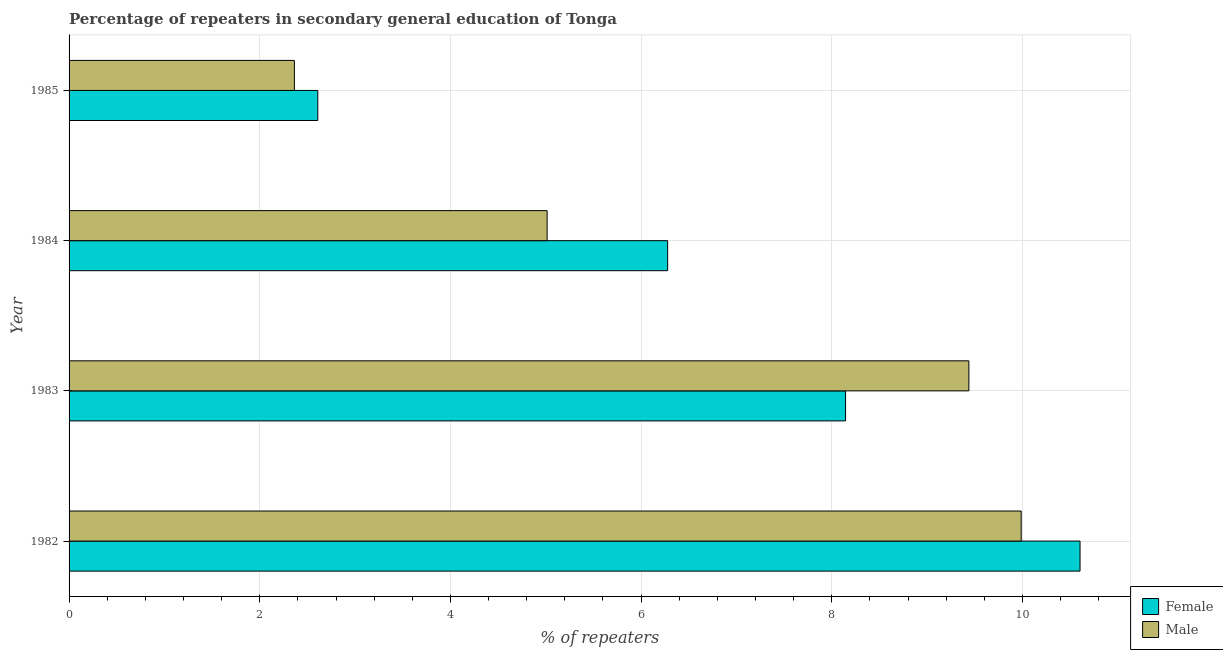How many different coloured bars are there?
Make the answer very short. 2. How many groups of bars are there?
Give a very brief answer. 4. Are the number of bars per tick equal to the number of legend labels?
Provide a short and direct response. Yes. How many bars are there on the 1st tick from the bottom?
Keep it short and to the point. 2. What is the percentage of female repeaters in 1984?
Your response must be concise. 6.28. Across all years, what is the maximum percentage of male repeaters?
Your answer should be very brief. 9.99. Across all years, what is the minimum percentage of female repeaters?
Provide a short and direct response. 2.61. What is the total percentage of male repeaters in the graph?
Provide a succinct answer. 26.8. What is the difference between the percentage of male repeaters in 1983 and that in 1985?
Provide a short and direct response. 7.08. What is the difference between the percentage of male repeaters in 1985 and the percentage of female repeaters in 1982?
Ensure brevity in your answer.  -8.24. What is the average percentage of female repeaters per year?
Your response must be concise. 6.91. In the year 1983, what is the difference between the percentage of female repeaters and percentage of male repeaters?
Your answer should be compact. -1.29. What is the ratio of the percentage of male repeaters in 1983 to that in 1985?
Keep it short and to the point. 3.99. Is the percentage of male repeaters in 1983 less than that in 1985?
Your answer should be very brief. No. What is the difference between the highest and the second highest percentage of male repeaters?
Ensure brevity in your answer.  0.55. What is the difference between the highest and the lowest percentage of male repeaters?
Offer a very short reply. 7.62. How many bars are there?
Provide a short and direct response. 8. How many years are there in the graph?
Ensure brevity in your answer.  4. What is the difference between two consecutive major ticks on the X-axis?
Your answer should be very brief. 2. Does the graph contain any zero values?
Make the answer very short. No. What is the title of the graph?
Provide a short and direct response. Percentage of repeaters in secondary general education of Tonga. What is the label or title of the X-axis?
Give a very brief answer. % of repeaters. What is the label or title of the Y-axis?
Make the answer very short. Year. What is the % of repeaters in Female in 1982?
Your answer should be very brief. 10.6. What is the % of repeaters of Male in 1982?
Provide a short and direct response. 9.99. What is the % of repeaters in Female in 1983?
Ensure brevity in your answer.  8.14. What is the % of repeaters of Male in 1983?
Make the answer very short. 9.44. What is the % of repeaters of Female in 1984?
Give a very brief answer. 6.28. What is the % of repeaters in Male in 1984?
Offer a terse response. 5.01. What is the % of repeaters in Female in 1985?
Offer a very short reply. 2.61. What is the % of repeaters in Male in 1985?
Keep it short and to the point. 2.36. Across all years, what is the maximum % of repeaters in Female?
Your answer should be very brief. 10.6. Across all years, what is the maximum % of repeaters of Male?
Provide a succinct answer. 9.99. Across all years, what is the minimum % of repeaters of Female?
Your response must be concise. 2.61. Across all years, what is the minimum % of repeaters in Male?
Ensure brevity in your answer.  2.36. What is the total % of repeaters in Female in the graph?
Your answer should be very brief. 27.64. What is the total % of repeaters in Male in the graph?
Your answer should be compact. 26.8. What is the difference between the % of repeaters in Female in 1982 and that in 1983?
Provide a short and direct response. 2.46. What is the difference between the % of repeaters of Male in 1982 and that in 1983?
Keep it short and to the point. 0.55. What is the difference between the % of repeaters of Female in 1982 and that in 1984?
Your response must be concise. 4.33. What is the difference between the % of repeaters of Male in 1982 and that in 1984?
Ensure brevity in your answer.  4.97. What is the difference between the % of repeaters of Female in 1982 and that in 1985?
Keep it short and to the point. 8. What is the difference between the % of repeaters in Male in 1982 and that in 1985?
Give a very brief answer. 7.62. What is the difference between the % of repeaters of Female in 1983 and that in 1984?
Give a very brief answer. 1.87. What is the difference between the % of repeaters in Male in 1983 and that in 1984?
Ensure brevity in your answer.  4.42. What is the difference between the % of repeaters of Female in 1983 and that in 1985?
Provide a short and direct response. 5.54. What is the difference between the % of repeaters of Male in 1983 and that in 1985?
Make the answer very short. 7.08. What is the difference between the % of repeaters in Female in 1984 and that in 1985?
Keep it short and to the point. 3.67. What is the difference between the % of repeaters of Male in 1984 and that in 1985?
Make the answer very short. 2.65. What is the difference between the % of repeaters in Female in 1982 and the % of repeaters in Male in 1983?
Your answer should be compact. 1.17. What is the difference between the % of repeaters of Female in 1982 and the % of repeaters of Male in 1984?
Make the answer very short. 5.59. What is the difference between the % of repeaters in Female in 1982 and the % of repeaters in Male in 1985?
Your answer should be compact. 8.24. What is the difference between the % of repeaters in Female in 1983 and the % of repeaters in Male in 1984?
Offer a terse response. 3.13. What is the difference between the % of repeaters in Female in 1983 and the % of repeaters in Male in 1985?
Provide a short and direct response. 5.78. What is the difference between the % of repeaters in Female in 1984 and the % of repeaters in Male in 1985?
Provide a succinct answer. 3.92. What is the average % of repeaters of Female per year?
Make the answer very short. 6.91. What is the average % of repeaters of Male per year?
Your answer should be very brief. 6.7. In the year 1982, what is the difference between the % of repeaters in Female and % of repeaters in Male?
Ensure brevity in your answer.  0.62. In the year 1983, what is the difference between the % of repeaters in Female and % of repeaters in Male?
Your answer should be very brief. -1.29. In the year 1984, what is the difference between the % of repeaters in Female and % of repeaters in Male?
Your answer should be very brief. 1.26. In the year 1985, what is the difference between the % of repeaters of Female and % of repeaters of Male?
Your response must be concise. 0.25. What is the ratio of the % of repeaters of Female in 1982 to that in 1983?
Provide a short and direct response. 1.3. What is the ratio of the % of repeaters in Male in 1982 to that in 1983?
Offer a very short reply. 1.06. What is the ratio of the % of repeaters of Female in 1982 to that in 1984?
Offer a very short reply. 1.69. What is the ratio of the % of repeaters of Male in 1982 to that in 1984?
Make the answer very short. 1.99. What is the ratio of the % of repeaters of Female in 1982 to that in 1985?
Your response must be concise. 4.06. What is the ratio of the % of repeaters in Male in 1982 to that in 1985?
Your answer should be compact. 4.23. What is the ratio of the % of repeaters in Female in 1983 to that in 1984?
Keep it short and to the point. 1.3. What is the ratio of the % of repeaters in Male in 1983 to that in 1984?
Offer a terse response. 1.88. What is the ratio of the % of repeaters in Female in 1983 to that in 1985?
Provide a short and direct response. 3.12. What is the ratio of the % of repeaters in Male in 1983 to that in 1985?
Your answer should be compact. 3.99. What is the ratio of the % of repeaters of Female in 1984 to that in 1985?
Your answer should be very brief. 2.41. What is the ratio of the % of repeaters of Male in 1984 to that in 1985?
Make the answer very short. 2.12. What is the difference between the highest and the second highest % of repeaters in Female?
Ensure brevity in your answer.  2.46. What is the difference between the highest and the second highest % of repeaters of Male?
Keep it short and to the point. 0.55. What is the difference between the highest and the lowest % of repeaters in Female?
Your answer should be compact. 8. What is the difference between the highest and the lowest % of repeaters of Male?
Offer a terse response. 7.62. 